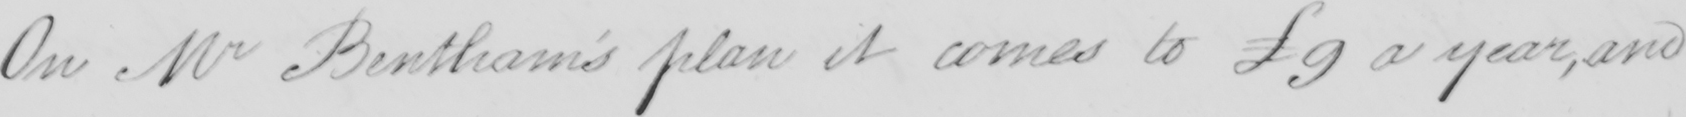Can you read and transcribe this handwriting? On Mr Bentham's plan it comes to £9 a year, and 